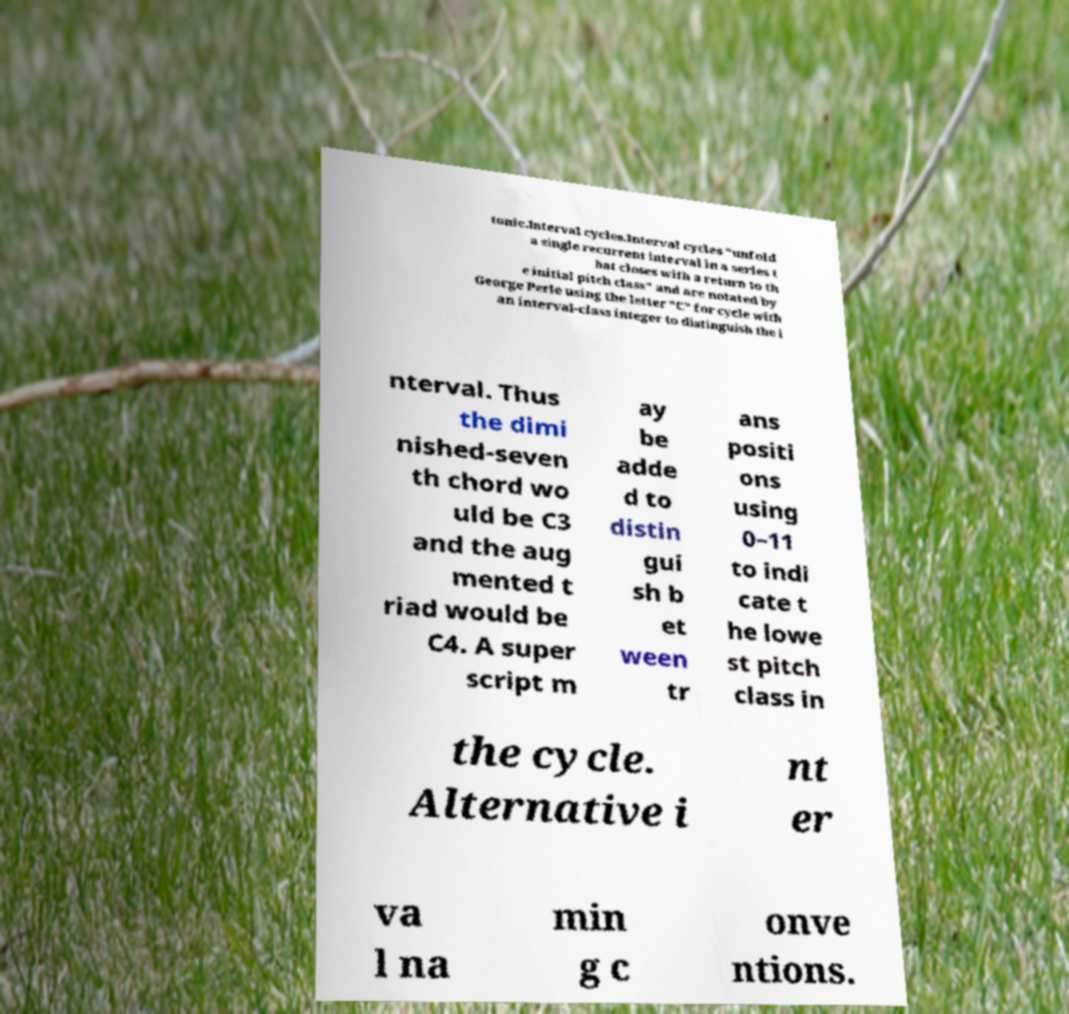Can you accurately transcribe the text from the provided image for me? tonic.Interval cycles.Interval cycles "unfold a single recurrent interval in a series t hat closes with a return to th e initial pitch class" and are notated by George Perle using the letter "C" for cycle with an interval-class integer to distinguish the i nterval. Thus the dimi nished-seven th chord wo uld be C3 and the aug mented t riad would be C4. A super script m ay be adde d to distin gui sh b et ween tr ans positi ons using 0–11 to indi cate t he lowe st pitch class in the cycle. Alternative i nt er va l na min g c onve ntions. 